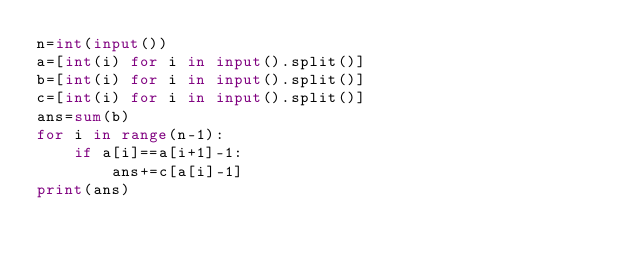<code> <loc_0><loc_0><loc_500><loc_500><_Python_>n=int(input())
a=[int(i) for i in input().split()]
b=[int(i) for i in input().split()]
c=[int(i) for i in input().split()]
ans=sum(b)
for i in range(n-1):
    if a[i]==a[i+1]-1:
        ans+=c[a[i]-1]
print(ans)</code> 